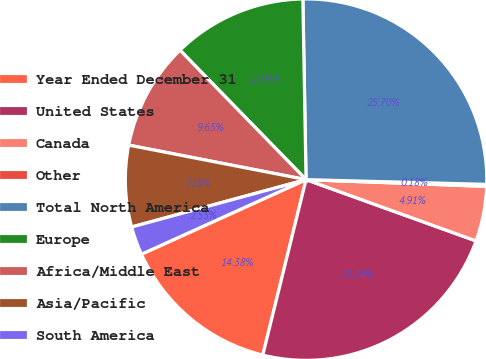Convert chart to OTSL. <chart><loc_0><loc_0><loc_500><loc_500><pie_chart><fcel>Year Ended December 31<fcel>United States<fcel>Canada<fcel>Other<fcel>Total North America<fcel>Europe<fcel>Africa/Middle East<fcel>Asia/Pacific<fcel>South America<nl><fcel>14.38%<fcel>23.34%<fcel>4.91%<fcel>0.18%<fcel>25.7%<fcel>12.01%<fcel>9.65%<fcel>7.28%<fcel>2.55%<nl></chart> 